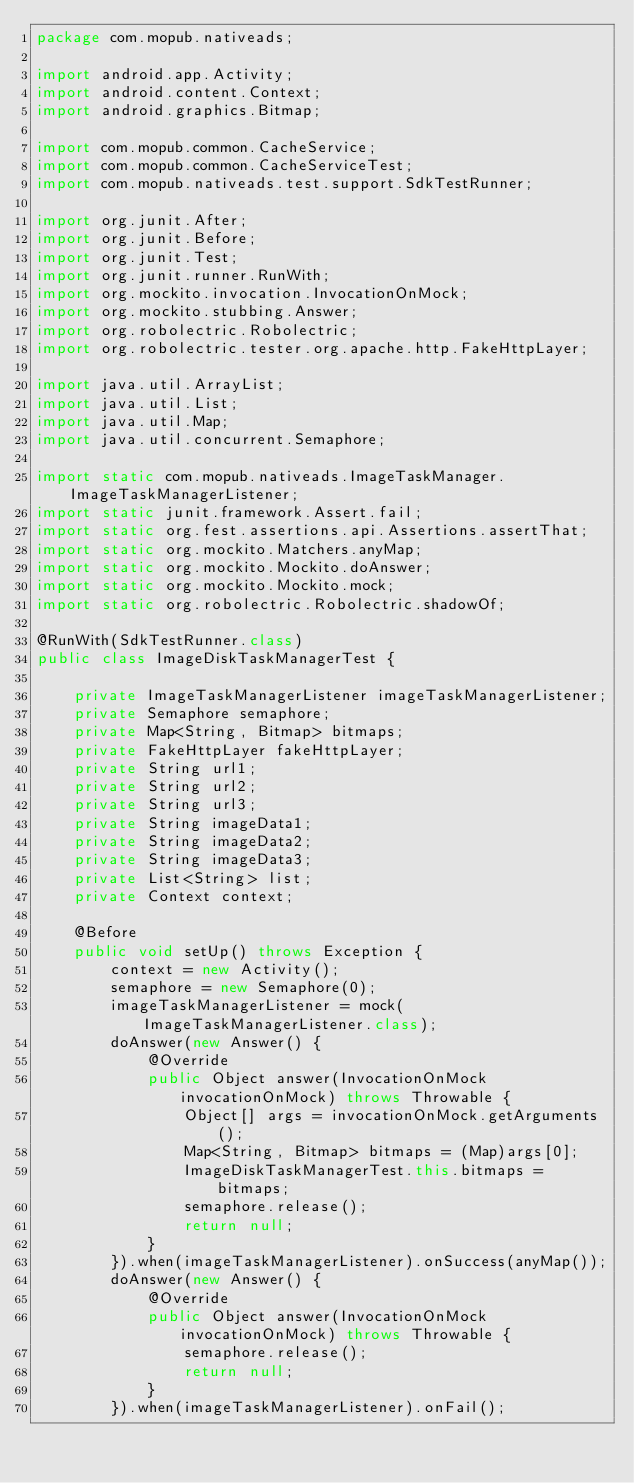<code> <loc_0><loc_0><loc_500><loc_500><_Java_>package com.mopub.nativeads;

import android.app.Activity;
import android.content.Context;
import android.graphics.Bitmap;

import com.mopub.common.CacheService;
import com.mopub.common.CacheServiceTest;
import com.mopub.nativeads.test.support.SdkTestRunner;

import org.junit.After;
import org.junit.Before;
import org.junit.Test;
import org.junit.runner.RunWith;
import org.mockito.invocation.InvocationOnMock;
import org.mockito.stubbing.Answer;
import org.robolectric.Robolectric;
import org.robolectric.tester.org.apache.http.FakeHttpLayer;

import java.util.ArrayList;
import java.util.List;
import java.util.Map;
import java.util.concurrent.Semaphore;

import static com.mopub.nativeads.ImageTaskManager.ImageTaskManagerListener;
import static junit.framework.Assert.fail;
import static org.fest.assertions.api.Assertions.assertThat;
import static org.mockito.Matchers.anyMap;
import static org.mockito.Mockito.doAnswer;
import static org.mockito.Mockito.mock;
import static org.robolectric.Robolectric.shadowOf;

@RunWith(SdkTestRunner.class)
public class ImageDiskTaskManagerTest {

    private ImageTaskManagerListener imageTaskManagerListener;
    private Semaphore semaphore;
    private Map<String, Bitmap> bitmaps;
    private FakeHttpLayer fakeHttpLayer;
    private String url1;
    private String url2;
    private String url3;
    private String imageData1;
    private String imageData2;
    private String imageData3;
    private List<String> list;
    private Context context;

    @Before
    public void setUp() throws Exception {
        context = new Activity();
        semaphore = new Semaphore(0);
        imageTaskManagerListener = mock(ImageTaskManagerListener.class);
        doAnswer(new Answer() {
            @Override
            public Object answer(InvocationOnMock invocationOnMock) throws Throwable {
                Object[] args = invocationOnMock.getArguments();
                Map<String, Bitmap> bitmaps = (Map)args[0];
                ImageDiskTaskManagerTest.this.bitmaps = bitmaps;
                semaphore.release();
                return null;
            }
        }).when(imageTaskManagerListener).onSuccess(anyMap());
        doAnswer(new Answer() {
            @Override
            public Object answer(InvocationOnMock invocationOnMock) throws Throwable {
                semaphore.release();
                return null;
            }
        }).when(imageTaskManagerListener).onFail();
</code> 